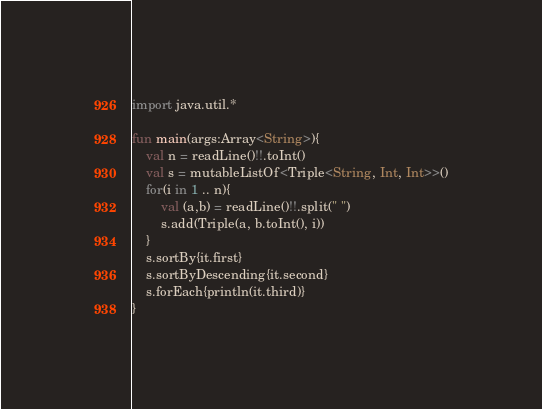Convert code to text. <code><loc_0><loc_0><loc_500><loc_500><_Kotlin_>import java.util.*

fun main(args:Array<String>){
    val n = readLine()!!.toInt()
    val s = mutableListOf<Triple<String, Int, Int>>()
    for(i in 1 .. n){
        val (a,b) = readLine()!!.split(" ")
        s.add(Triple(a, b.toInt(), i))
    }
    s.sortBy{it.first}
    s.sortByDescending{it.second}
    s.forEach{println(it.third)}
}
</code> 